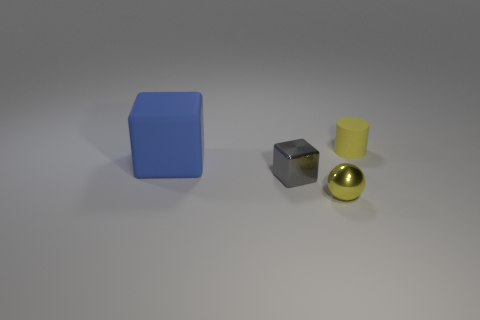Do the rubber thing that is to the left of the small cube and the small matte object have the same shape?
Provide a short and direct response. No. What number of things are both behind the gray shiny thing and right of the small gray block?
Offer a very short reply. 1. What number of blue matte objects are the same shape as the small gray shiny object?
Offer a terse response. 1. There is a thing on the right side of the yellow object in front of the blue object; what color is it?
Your answer should be very brief. Yellow. Is the shape of the big thing the same as the tiny yellow object that is behind the small shiny cube?
Ensure brevity in your answer.  No. The small yellow thing on the right side of the tiny yellow object in front of the tiny thing that is to the left of the small sphere is made of what material?
Your answer should be very brief. Rubber. Is there a brown cylinder that has the same size as the yellow ball?
Your response must be concise. No. There is another thing that is the same material as the big thing; what size is it?
Make the answer very short. Small. What shape is the tiny gray thing?
Offer a very short reply. Cube. Is the tiny cylinder made of the same material as the block that is left of the gray object?
Offer a very short reply. Yes. 